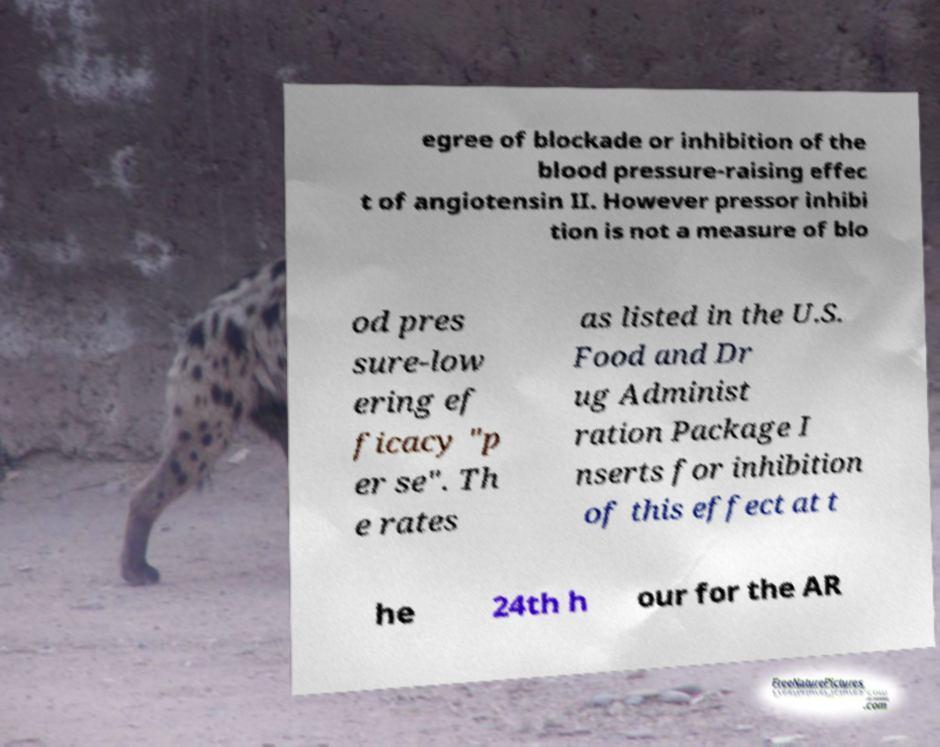Could you extract and type out the text from this image? egree of blockade or inhibition of the blood pressure-raising effec t of angiotensin II. However pressor inhibi tion is not a measure of blo od pres sure-low ering ef ficacy "p er se". Th e rates as listed in the U.S. Food and Dr ug Administ ration Package I nserts for inhibition of this effect at t he 24th h our for the AR 